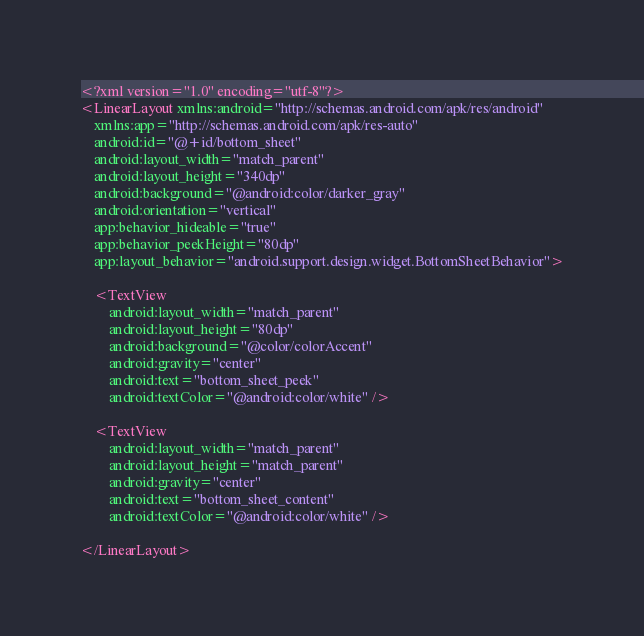Convert code to text. <code><loc_0><loc_0><loc_500><loc_500><_XML_><?xml version="1.0" encoding="utf-8"?>
<LinearLayout xmlns:android="http://schemas.android.com/apk/res/android"
    xmlns:app="http://schemas.android.com/apk/res-auto"
    android:id="@+id/bottom_sheet"
    android:layout_width="match_parent"
    android:layout_height="340dp"
    android:background="@android:color/darker_gray"
    android:orientation="vertical"
    app:behavior_hideable="true"
    app:behavior_peekHeight="80dp"
    app:layout_behavior="android.support.design.widget.BottomSheetBehavior">

    <TextView
        android:layout_width="match_parent"
        android:layout_height="80dp"
        android:background="@color/colorAccent"
        android:gravity="center"
        android:text="bottom_sheet_peek"
        android:textColor="@android:color/white" />

    <TextView
        android:layout_width="match_parent"
        android:layout_height="match_parent"
        android:gravity="center"
        android:text="bottom_sheet_content"
        android:textColor="@android:color/white" />

</LinearLayout></code> 